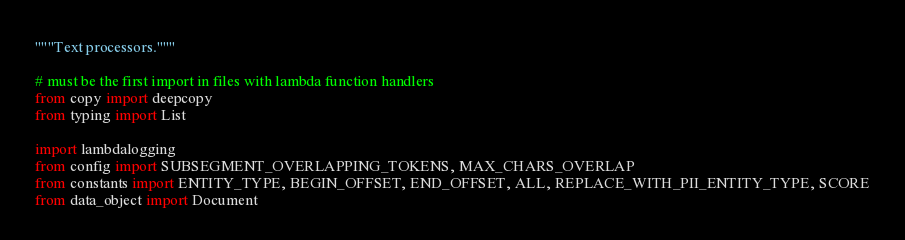Convert code to text. <code><loc_0><loc_0><loc_500><loc_500><_Python_>"""Text processors."""

# must be the first import in files with lambda function handlers
from copy import deepcopy
from typing import List

import lambdalogging
from config import SUBSEGMENT_OVERLAPPING_TOKENS, MAX_CHARS_OVERLAP
from constants import ENTITY_TYPE, BEGIN_OFFSET, END_OFFSET, ALL, REPLACE_WITH_PII_ENTITY_TYPE, SCORE
from data_object import Document</code> 